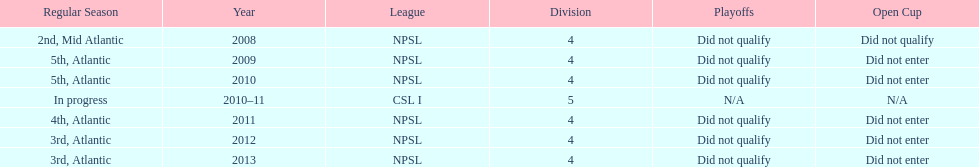Parse the full table. {'header': ['Regular Season', 'Year', 'League', 'Division', 'Playoffs', 'Open Cup'], 'rows': [['2nd, Mid Atlantic', '2008', 'NPSL', '4', 'Did not qualify', 'Did not qualify'], ['5th, Atlantic', '2009', 'NPSL', '4', 'Did not qualify', 'Did not enter'], ['5th, Atlantic', '2010', 'NPSL', '4', 'Did not qualify', 'Did not enter'], ['In progress', '2010–11', 'CSL I', '5', 'N/A', 'N/A'], ['4th, Atlantic', '2011', 'NPSL', '4', 'Did not qualify', 'Did not enter'], ['3rd, Atlantic', '2012', 'NPSL', '4', 'Did not qualify', 'Did not enter'], ['3rd, Atlantic', '2013', 'NPSL', '4', 'Did not qualify', 'Did not enter']]} In what year only did they compete in division 5 2010-11. 